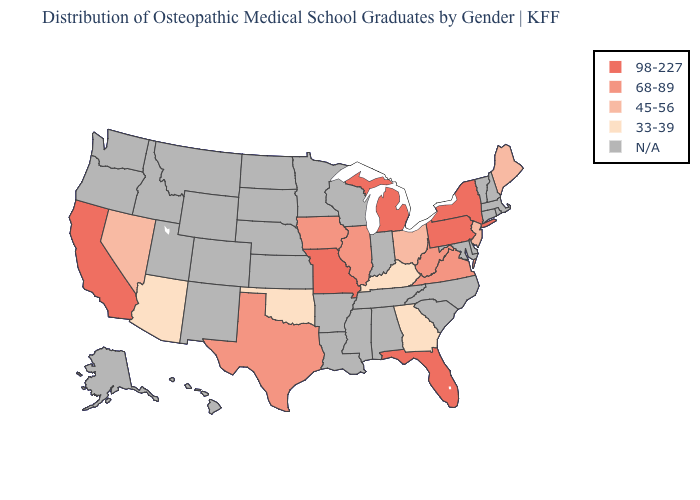Among the states that border Indiana , does Illinois have the lowest value?
Quick response, please. No. How many symbols are there in the legend?
Write a very short answer. 5. What is the value of Michigan?
Be succinct. 98-227. Name the states that have a value in the range N/A?
Short answer required. Alabama, Alaska, Arkansas, Colorado, Connecticut, Delaware, Hawaii, Idaho, Indiana, Kansas, Louisiana, Maryland, Massachusetts, Minnesota, Mississippi, Montana, Nebraska, New Hampshire, New Mexico, North Carolina, North Dakota, Oregon, Rhode Island, South Carolina, South Dakota, Tennessee, Utah, Vermont, Washington, Wisconsin, Wyoming. Does the map have missing data?
Keep it brief. Yes. Which states have the highest value in the USA?
Be succinct. California, Florida, Michigan, Missouri, New York, Pennsylvania. What is the highest value in the USA?
Give a very brief answer. 98-227. Name the states that have a value in the range N/A?
Give a very brief answer. Alabama, Alaska, Arkansas, Colorado, Connecticut, Delaware, Hawaii, Idaho, Indiana, Kansas, Louisiana, Maryland, Massachusetts, Minnesota, Mississippi, Montana, Nebraska, New Hampshire, New Mexico, North Carolina, North Dakota, Oregon, Rhode Island, South Carolina, South Dakota, Tennessee, Utah, Vermont, Washington, Wisconsin, Wyoming. What is the highest value in the USA?
Give a very brief answer. 98-227. Name the states that have a value in the range 68-89?
Keep it brief. Illinois, Iowa, Texas, Virginia, West Virginia. Name the states that have a value in the range 98-227?
Be succinct. California, Florida, Michigan, Missouri, New York, Pennsylvania. 